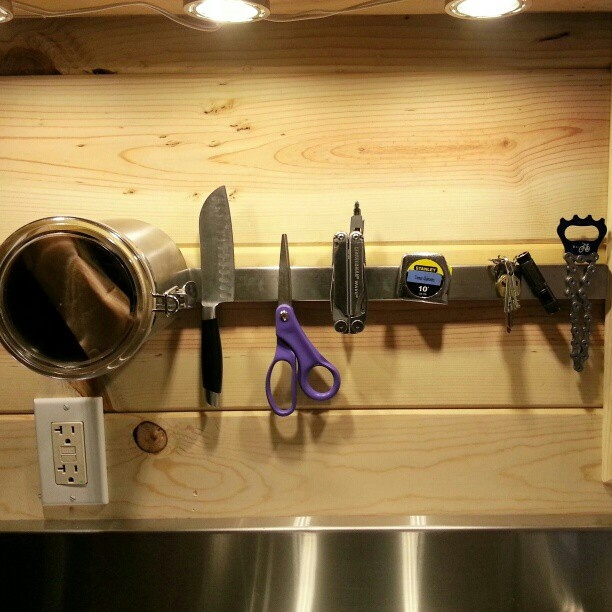Describe the objects in this image and their specific colors. I can see scissors in olive, purple, tan, and black tones, knife in olive, gray, and black tones, and knife in olive, black, and gray tones in this image. 